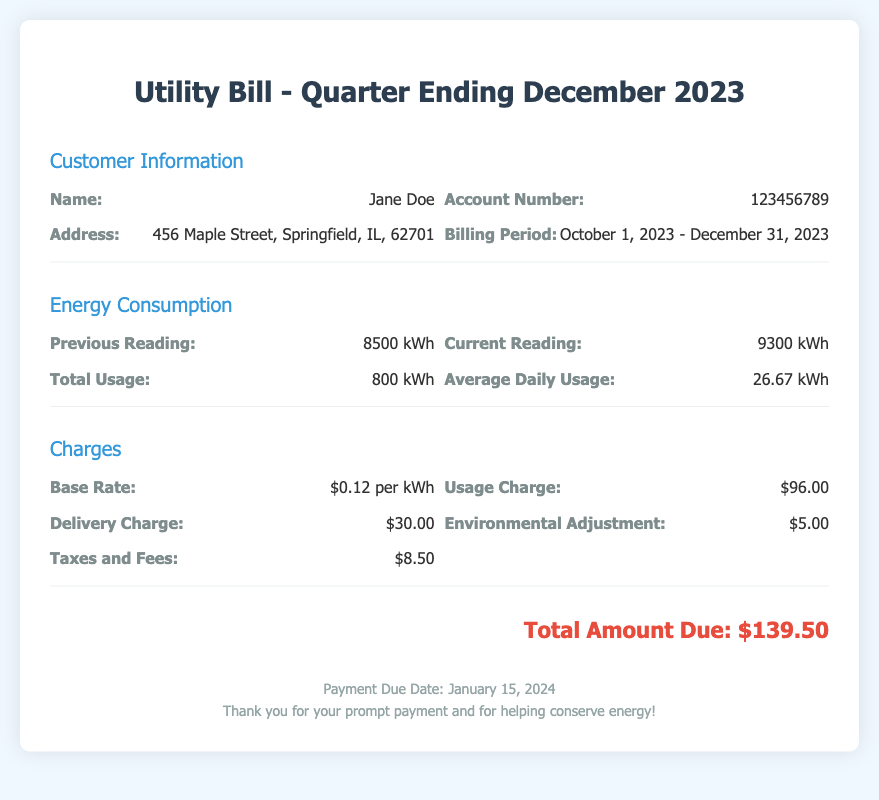What is the name of the customer? The name of the customer is found in the customer information section of the document.
Answer: Jane Doe What is the account number? The account number is listed under customer information in the document.
Answer: 123456789 What is the total usage of energy for the billing period? Total usage is calculated by subtracting the previous reading from the current reading in the energy consumption section.
Answer: 800 kWh What is the average daily usage? Average daily usage is included in the energy consumption part and is calculated based on total usage and days in the billing period.
Answer: 26.67 kWh What is the base rate per kWh? The base rate is specified in the charges section of the document.
Answer: $0.12 per kWh What is the delivery charge? The delivery charge is included in the charges section of the utility bill.
Answer: $30.00 What is the total amount due? The total amount due is the sum of all charges indicated at the end of the document.
Answer: $139.50 When is the payment due date? The payment due date is provided in the footer of the document.
Answer: January 15, 2024 What is the environmental adjustment fee? The environmental adjustment fee is listed under charges in the document.
Answer: $5.00 